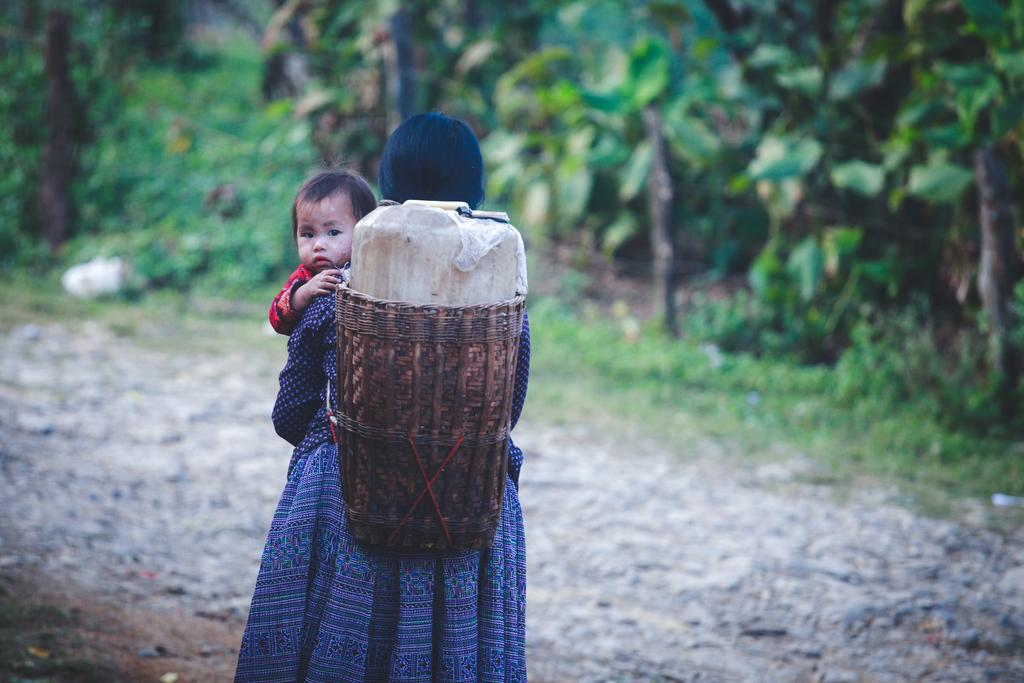Who is the main subject in the image? There is a woman in the image. What is the woman doing in the image? The woman is carrying a child in a basket on her back. What type of vegetation can be seen in the background of the image? There is grass and trees visible in the background of the image. What type of credit card does the woman have in her hand in the image? There is no credit card visible in the image; the woman is carrying a child in a basket on her back. 